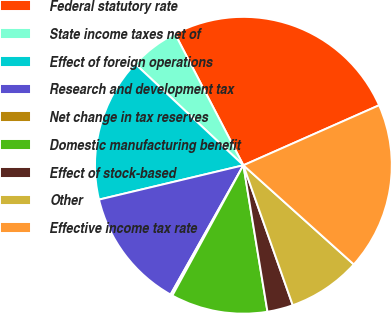Convert chart to OTSL. <chart><loc_0><loc_0><loc_500><loc_500><pie_chart><fcel>Federal statutory rate<fcel>State income taxes net of<fcel>Effect of foreign operations<fcel>Research and development tax<fcel>Net change in tax reserves<fcel>Domestic manufacturing benefit<fcel>Effect of stock-based<fcel>Other<fcel>Effective income tax rate<nl><fcel>26.01%<fcel>5.38%<fcel>15.7%<fcel>13.12%<fcel>0.22%<fcel>10.54%<fcel>2.8%<fcel>7.96%<fcel>18.27%<nl></chart> 